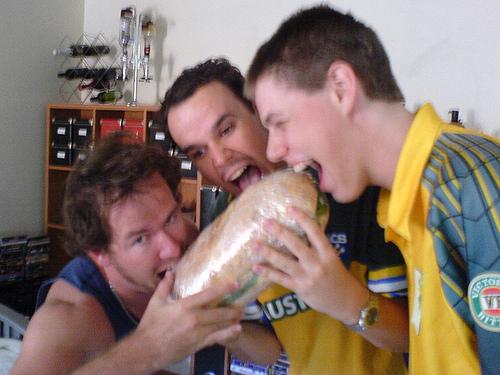What 2 letters are visible on the yellow apron?
Answer briefly. Us. What are the men pretending to eat?
Keep it brief. Sandwich. Where is the sleeveless shirt?
Be succinct. Guy on left. 